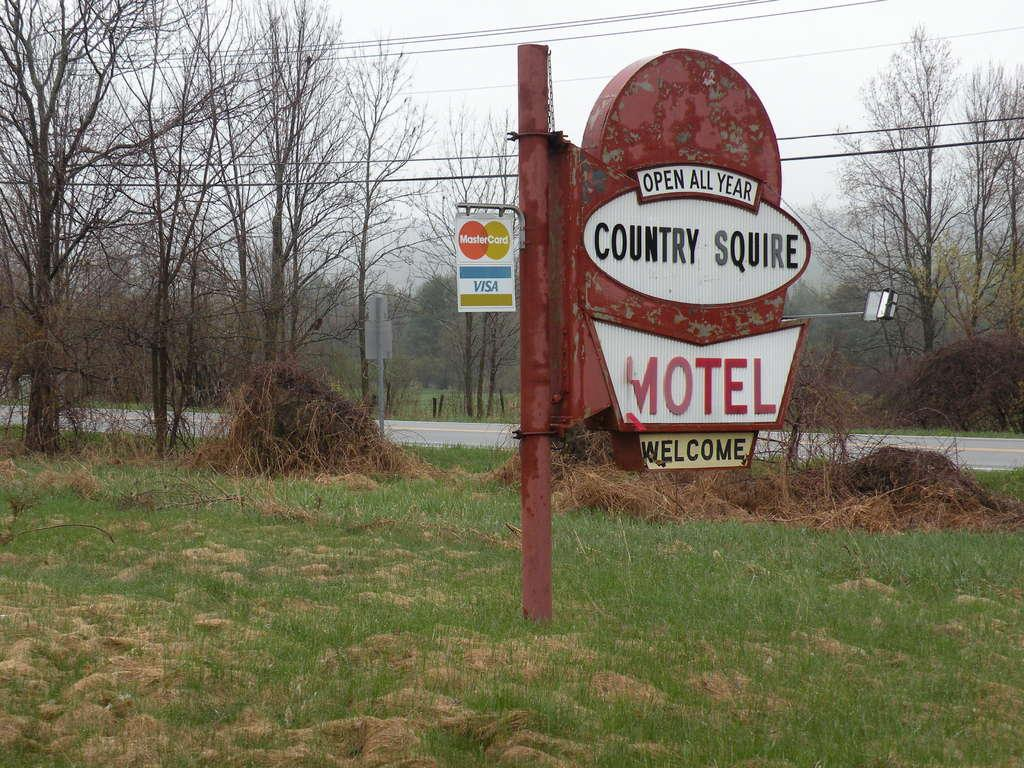What is the main object in the image? There is a welcome board in the image. How is the welcome board positioned in the image? The welcome board is dug into the ground. What type of natural environment is visible in the image? There are many trees visible in the image. What type of thrill can be experienced by the umbrella in the image? There is no umbrella present in the image, so it cannot be determined if any thrill is experienced. 